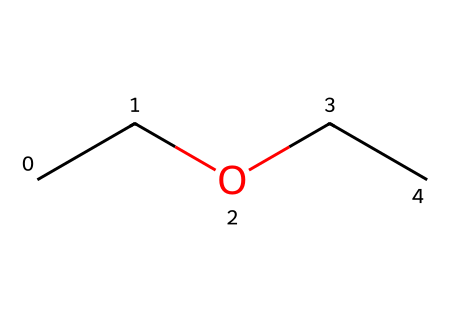What is the total number of carbon atoms in diethyl ether? The SMILES representation "CCOCC" indicates there are four 'C' symbols in the structure, representing four carbon atoms.
Answer: four How many oxygen atoms are present in diethyl ether? In the SMILES "CCOCC," there is one 'O' symbol, signifying one oxygen atom in the molecule.
Answer: one What is the common use of diethyl ether in a medical context? Diethyl ether is used as an anesthetic agent in various medical and surgical procedures.
Answer: anesthetic Is diethyl ether a polar or non-polar molecule? Given its molecular structure, diethyl ether has a significant presence of carbon with limited polarity from the oxygen, making it predominantly non-polar.
Answer: non-polar What functional group is present in diethyl ether? The ether functional group is characterized by an oxygen atom bonded to two alkyl or aryl groups, which is evident in the structure of diethyl ether.
Answer: ether How many hydrogen atoms are in diethyl ether? Each carbon typically forms four bonds, and in this configuration, there are ten hydrogen atoms surrounding the four carbon atoms in diethyl ether.
Answer: ten What type of chemical bond connects the carbon and oxygen atoms in diethyl ether? The carbon and oxygen atoms in diethyl ether are connected by single covalent bonds, as indicated by the structure in the SMILES.
Answer: single covalent 